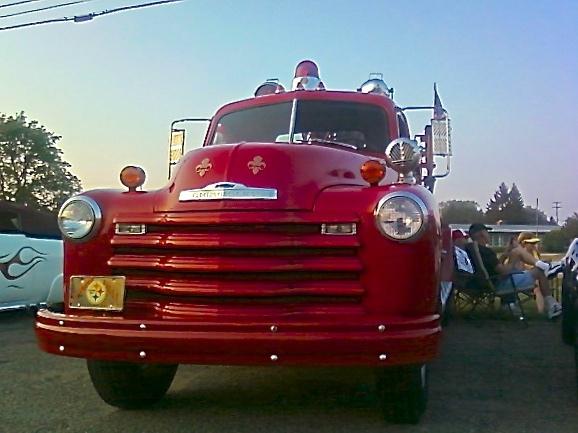Are there any people next to the truck?
Give a very brief answer. Yes. Who is the maker of this truck?
Concise answer only. Ford. What type of truck is this?
Write a very short answer. Fire truck. Is this a red fire truck?
Keep it brief. Yes. What is the driver of this vehicle's likely profession?
Quick response, please. Fireman. 